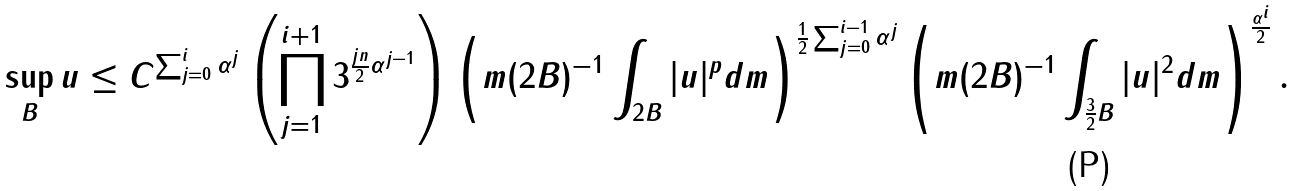<formula> <loc_0><loc_0><loc_500><loc_500>\sup _ { B } u \leq C ^ { \sum _ { j = 0 } ^ { i } \alpha ^ { j } } \left ( \prod _ { j = 1 } ^ { i + 1 } 3 ^ { \frac { j n } 2 \alpha ^ { j - 1 } } \right ) \left ( m ( 2 B ) ^ { - 1 } \int _ { 2 B } | u | ^ { p } d m \right ) ^ { \frac { 1 } { 2 } \sum _ { j = 0 } ^ { i - 1 } \alpha ^ { j } } \left ( m ( 2 B ) ^ { - 1 } \int _ { \frac { 3 } { 2 } B } | u | ^ { 2 } d m \right ) ^ { \frac { \alpha ^ { i } } 2 } .</formula> 